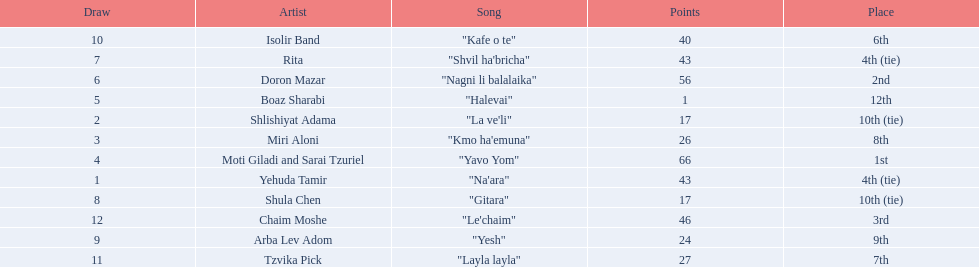Who were all the artists at the contest? Yehuda Tamir, Shlishiyat Adama, Miri Aloni, Moti Giladi and Sarai Tzuriel, Boaz Sharabi, Doron Mazar, Rita, Shula Chen, Arba Lev Adom, Isolir Band, Tzvika Pick, Chaim Moshe. What were their point totals? 43, 17, 26, 66, 1, 56, 43, 17, 24, 40, 27, 46. Of these, which is the least amount of points? 1. Which artists received this point total? Boaz Sharabi. 